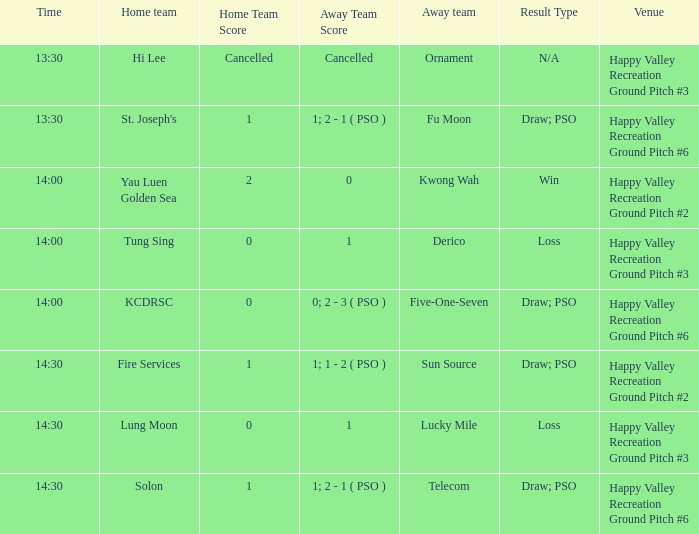What is the score of the match at happy valley recreation ground pitch #2 with a 14:30 time? 1 - 1; 1 - 2 ( PSO ). 